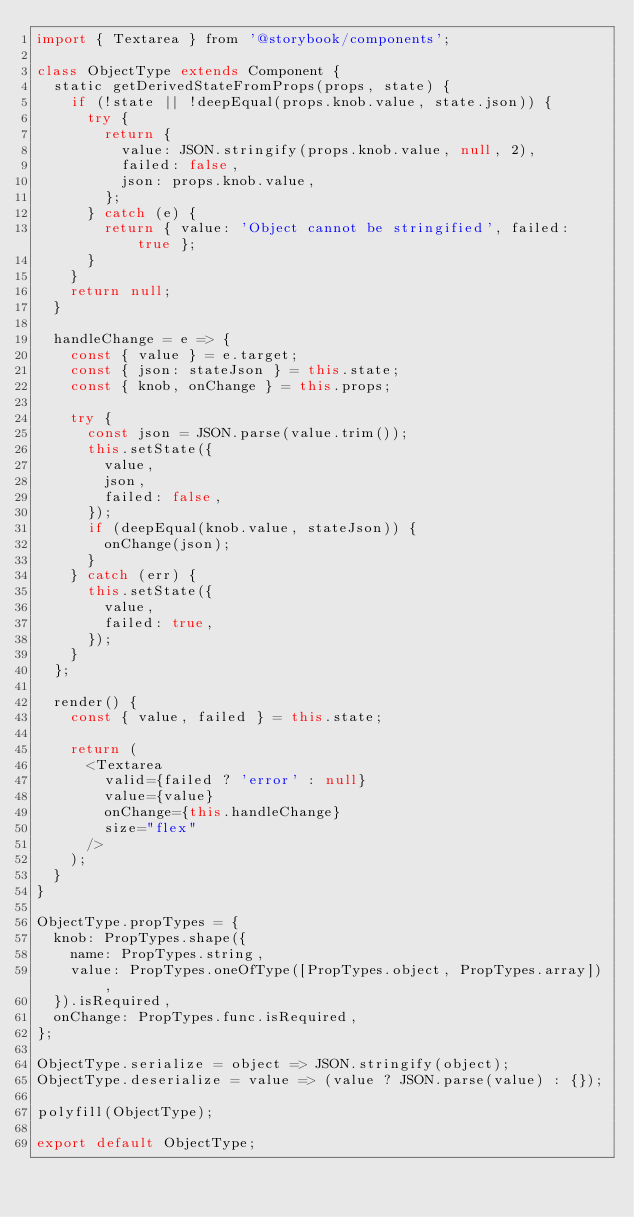Convert code to text. <code><loc_0><loc_0><loc_500><loc_500><_JavaScript_>import { Textarea } from '@storybook/components';

class ObjectType extends Component {
  static getDerivedStateFromProps(props, state) {
    if (!state || !deepEqual(props.knob.value, state.json)) {
      try {
        return {
          value: JSON.stringify(props.knob.value, null, 2),
          failed: false,
          json: props.knob.value,
        };
      } catch (e) {
        return { value: 'Object cannot be stringified', failed: true };
      }
    }
    return null;
  }

  handleChange = e => {
    const { value } = e.target;
    const { json: stateJson } = this.state;
    const { knob, onChange } = this.props;

    try {
      const json = JSON.parse(value.trim());
      this.setState({
        value,
        json,
        failed: false,
      });
      if (deepEqual(knob.value, stateJson)) {
        onChange(json);
      }
    } catch (err) {
      this.setState({
        value,
        failed: true,
      });
    }
  };

  render() {
    const { value, failed } = this.state;

    return (
      <Textarea
        valid={failed ? 'error' : null}
        value={value}
        onChange={this.handleChange}
        size="flex"
      />
    );
  }
}

ObjectType.propTypes = {
  knob: PropTypes.shape({
    name: PropTypes.string,
    value: PropTypes.oneOfType([PropTypes.object, PropTypes.array]),
  }).isRequired,
  onChange: PropTypes.func.isRequired,
};

ObjectType.serialize = object => JSON.stringify(object);
ObjectType.deserialize = value => (value ? JSON.parse(value) : {});

polyfill(ObjectType);

export default ObjectType;
</code> 